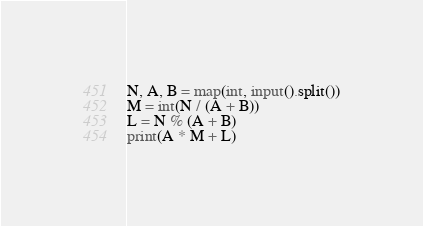Convert code to text. <code><loc_0><loc_0><loc_500><loc_500><_Python_>N, A, B = map(int, input().split())
M = int(N / (A + B))
L = N % (A + B)
print(A * M + L)</code> 